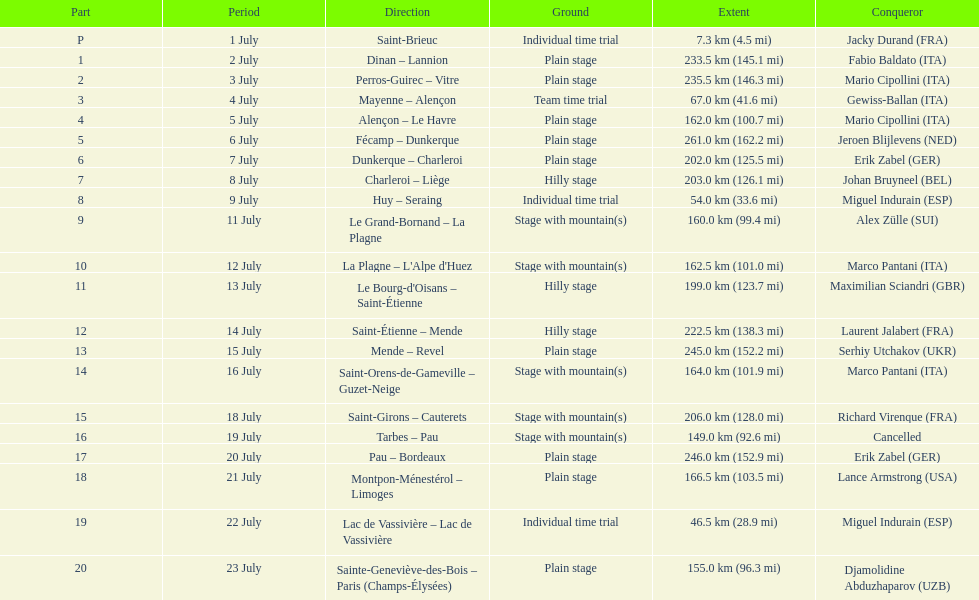How many routes cover less than 100 km in total? 4. 